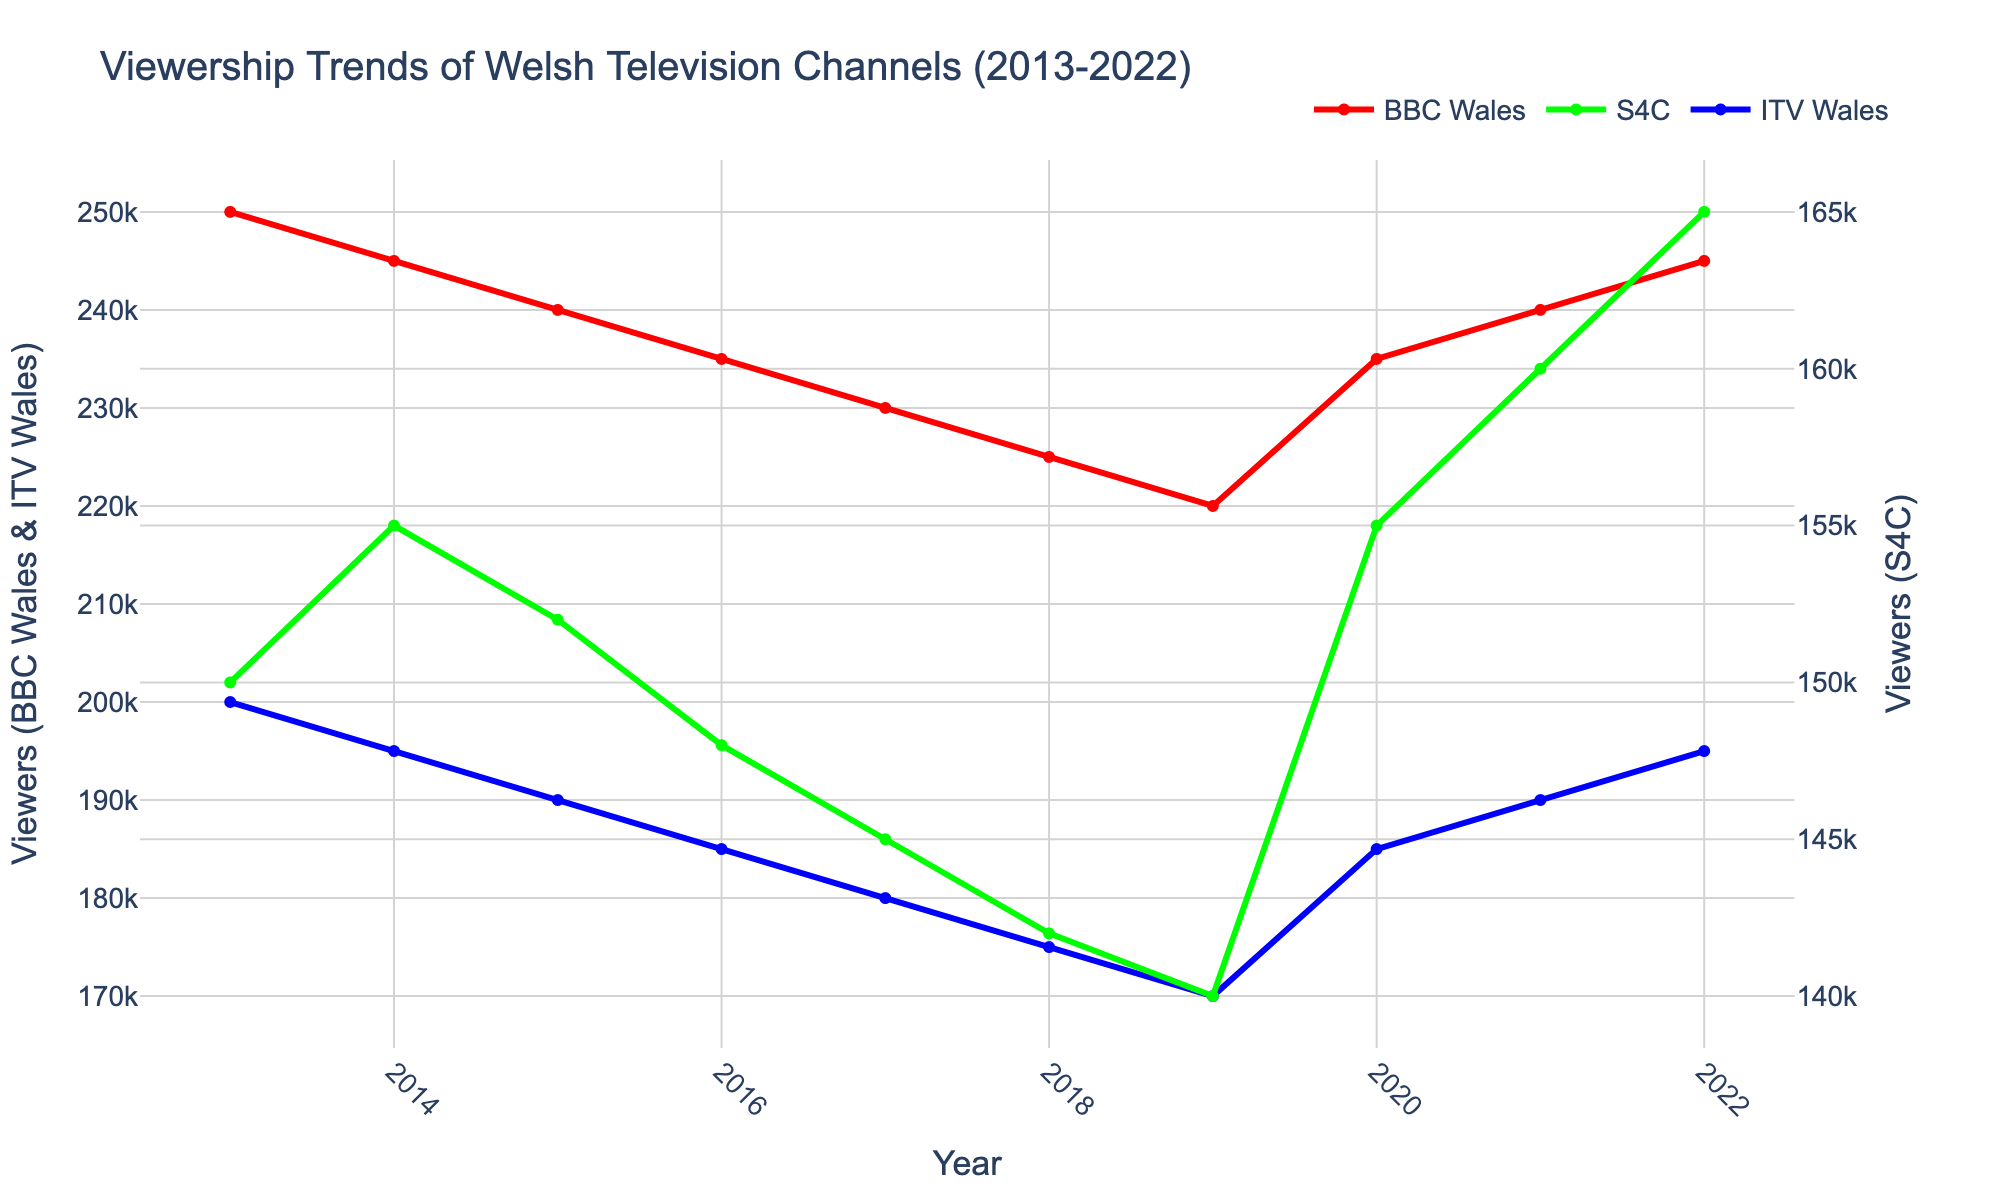what's the title of the figure? The title is located at the top of the figure and provides a summary of the plot content.
Answer: "Viewership Trends of Welsh Television Channels (2013-2022)" what are the y-axis labels? The y-axis labels are located along the vertical axes and describe what is being measured. The left y-axis is labeled "Viewers (BBC Wales & ITV Wales)", and the right y-axis is labeled "Viewers (S4C)".
Answer: "Viewers (BBC Wales & ITV Wales)" and "Viewers (S4C)" how do the viewership numbers for S4C change from 2013 to 2022? By tracing the line corresponding to S4C from 2013 to 2022, we see the values range from 150,000 to 165,000 viewers.
Answer: the viewership increased from 150,000 to 165,000 which channel had the most significant dip in viewers between 2013 and 2022? Observing the lines, BBC Wales and ITV Wales show a consistent decline, but ITV Wales shows a larger decrease from 200,000 to 195,000, whereas BBC Wales declines more.
Answer: BBC Wales in which years did the viewership for all channels trend upward? All lines show an increase between the years 2019 and 2022. Additionally, there is a visible increase in 2020 compared to 2019.
Answer: 2020 and 2021 what are the viewership trends for ITV Wales between 2013 and 2019? Observing the blue line for ITV Wales from 2013 to 2019, the trend shows a consistent decline from around 200,000 viewers to 170,000 viewers.
Answer: a decline compare the viewership trends for BBC Wales and S4C between 2013 and 2022. BBC Wales consistently declines from 250,000 to 240,000 viewers, while S4C largely remains stable with a slight increase from 150,000 to 165,000 viewers toward the end.
Answer: BBC Wales declines, S4C remains roughly stable with a slight increase calculate the average viewership for S4C from 2013 to 2022. Sum the viewership numbers for S4C from each year and divide by the number of years (10): (150,000 + 155,000 + 152,000 + 148,000 + 145,000 + 142,000 + 140,000 + 155,000 + 160,000 + 165,000) / 10 = 151,200 viewers.
Answer: 151,200 viewers what is the difference in viewership between BBC Wales and ITV Wales in 2022? For 2022, viewership for BBC Wales is 245,000 and for ITV Wales is 195,000, the difference is 245,000 - 195,000 = 50,000.
Answer: 50,000 